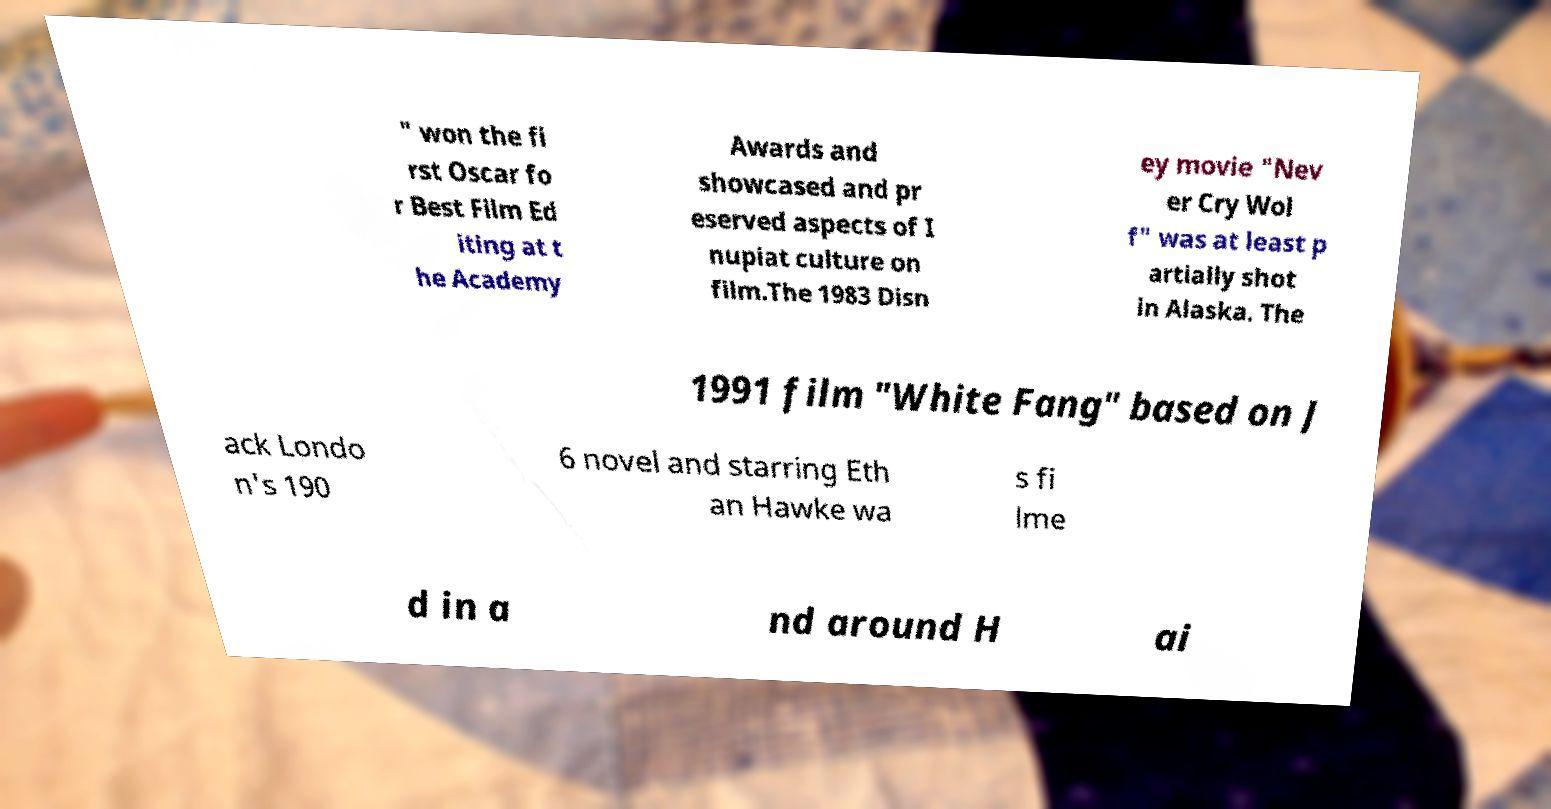For documentation purposes, I need the text within this image transcribed. Could you provide that? " won the fi rst Oscar fo r Best Film Ed iting at t he Academy Awards and showcased and pr eserved aspects of I nupiat culture on film.The 1983 Disn ey movie "Nev er Cry Wol f" was at least p artially shot in Alaska. The 1991 film "White Fang" based on J ack Londo n's 190 6 novel and starring Eth an Hawke wa s fi lme d in a nd around H ai 